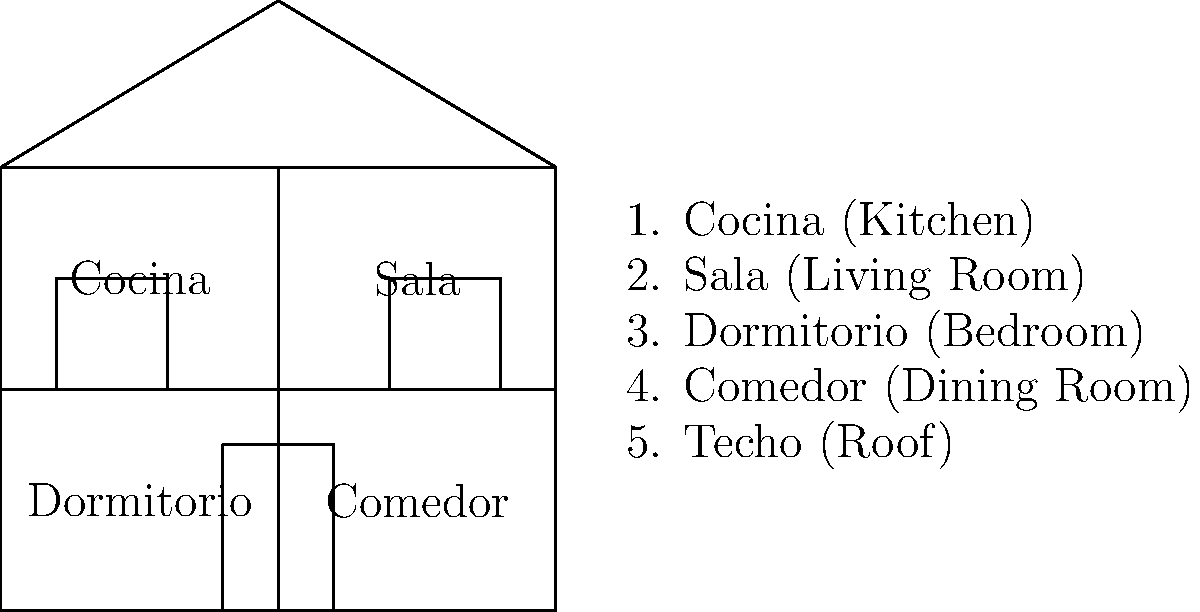In the cutaway diagram of a traditional Mexican house, which room is typically located in the front part of the house and serves as a gathering place for family and guests? To answer this question, let's analyze the layout of the traditional Mexican house shown in the diagram:

1. The house is divided into four main rooms.
2. The front of the house is represented by the bottom of the diagram.
3. The rooms are labeled as follows:
   - Top left: Cocina (Kitchen)
   - Top right: Sala (Living Room)
   - Bottom left: Dormitorio (Bedroom)
   - Bottom right: Comedor (Dining Room)
4. In traditional Mexican culture, the sala (living room) is typically located in the front part of the house.
5. The sala serves as a gathering place for family members and is used to receive guests.
6. In the diagram, we can see that the sala is indeed located in the front right corner of the house.

Therefore, based on the layout and cultural significance, the room located in the front part of the house that serves as a gathering place for family and guests is the sala (living room).
Answer: Sala (Living Room) 